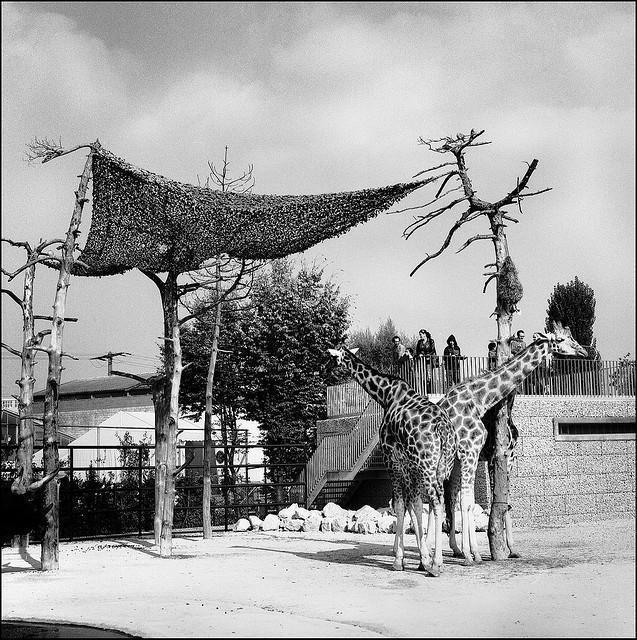Why are the people behind rails?
Answer the question by selecting the correct answer among the 4 following choices and explain your choice with a short sentence. The answer should be formatted with the following format: `Answer: choice
Rationale: rationale.`
Options: See better, protect giraffes, protect them, keep clean. Answer: protect them.
Rationale: The giraffes are at a zoo. 